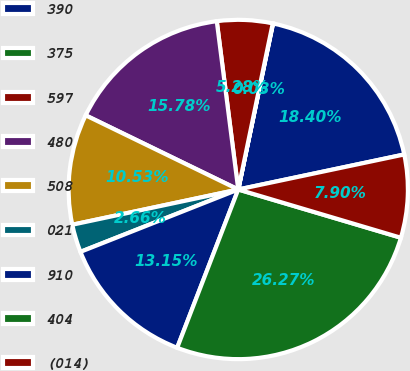Convert chart. <chart><loc_0><loc_0><loc_500><loc_500><pie_chart><fcel>390<fcel>375<fcel>597<fcel>480<fcel>508<fcel>021<fcel>910<fcel>404<fcel>(014)<nl><fcel>18.4%<fcel>0.03%<fcel>5.28%<fcel>15.78%<fcel>10.53%<fcel>2.66%<fcel>13.15%<fcel>26.27%<fcel>7.9%<nl></chart> 